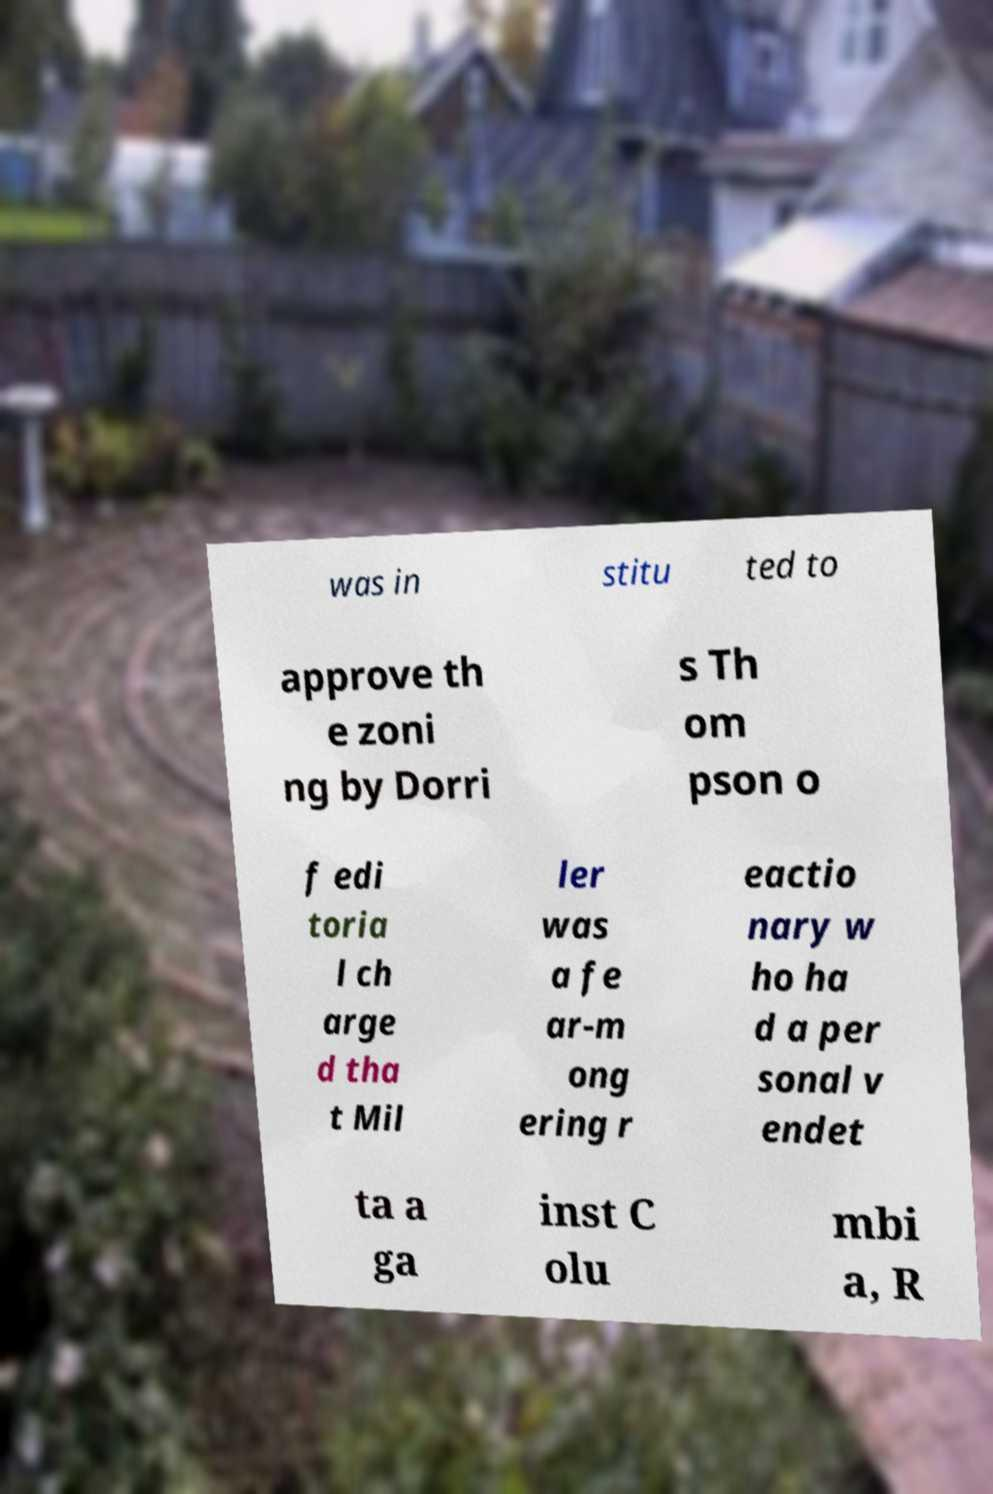There's text embedded in this image that I need extracted. Can you transcribe it verbatim? was in stitu ted to approve th e zoni ng by Dorri s Th om pson o f edi toria l ch arge d tha t Mil ler was a fe ar-m ong ering r eactio nary w ho ha d a per sonal v endet ta a ga inst C olu mbi a, R 